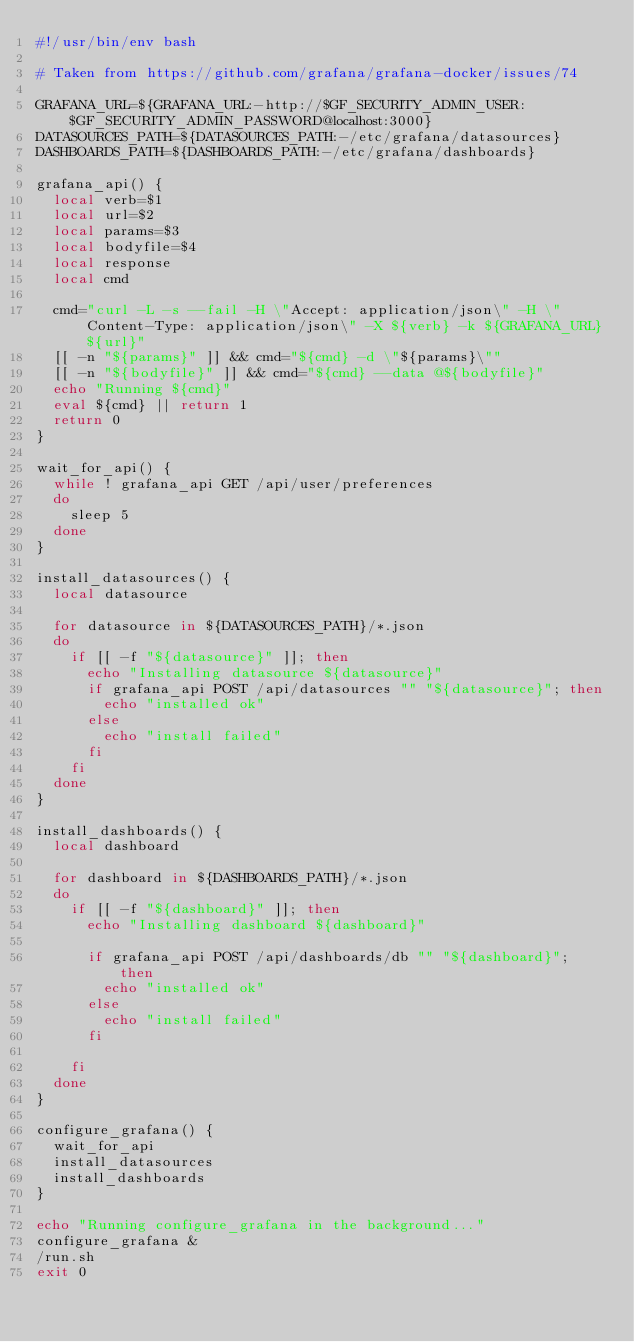Convert code to text. <code><loc_0><loc_0><loc_500><loc_500><_Bash_>#!/usr/bin/env bash

# Taken from https://github.com/grafana/grafana-docker/issues/74

GRAFANA_URL=${GRAFANA_URL:-http://$GF_SECURITY_ADMIN_USER:$GF_SECURITY_ADMIN_PASSWORD@localhost:3000}
DATASOURCES_PATH=${DATASOURCES_PATH:-/etc/grafana/datasources}
DASHBOARDS_PATH=${DASHBOARDS_PATH:-/etc/grafana/dashboards}

grafana_api() {
  local verb=$1
  local url=$2
  local params=$3
  local bodyfile=$4
  local response
  local cmd

  cmd="curl -L -s --fail -H \"Accept: application/json\" -H \"Content-Type: application/json\" -X ${verb} -k ${GRAFANA_URL}${url}"
  [[ -n "${params}" ]] && cmd="${cmd} -d \"${params}\""
  [[ -n "${bodyfile}" ]] && cmd="${cmd} --data @${bodyfile}"
  echo "Running ${cmd}"
  eval ${cmd} || return 1
  return 0
}

wait_for_api() {
  while ! grafana_api GET /api/user/preferences
  do
    sleep 5
  done 
}

install_datasources() {
  local datasource

  for datasource in ${DATASOURCES_PATH}/*.json
  do
    if [[ -f "${datasource}" ]]; then
      echo "Installing datasource ${datasource}"
      if grafana_api POST /api/datasources "" "${datasource}"; then
        echo "installed ok"
      else
        echo "install failed"
      fi
    fi
  done
}

install_dashboards() {
  local dashboard

  for dashboard in ${DASHBOARDS_PATH}/*.json
  do
    if [[ -f "${dashboard}" ]]; then
      echo "Installing dashboard ${dashboard}"

      if grafana_api POST /api/dashboards/db "" "${dashboard}"; then
        echo "installed ok"
      else
        echo "install failed"
      fi

    fi
  done
}

configure_grafana() {
  wait_for_api
  install_datasources
  install_dashboards
}

echo "Running configure_grafana in the background..."
configure_grafana &
/run.sh
exit 0
</code> 